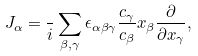<formula> <loc_0><loc_0><loc_500><loc_500>J _ { \alpha } = \frac { } { i } \sum _ { \beta , \gamma } \epsilon _ { \alpha \beta \gamma } \frac { c _ { \gamma } } { c _ { \beta } } x _ { \beta } \frac { \partial } { \partial x _ { \gamma } } ,</formula> 